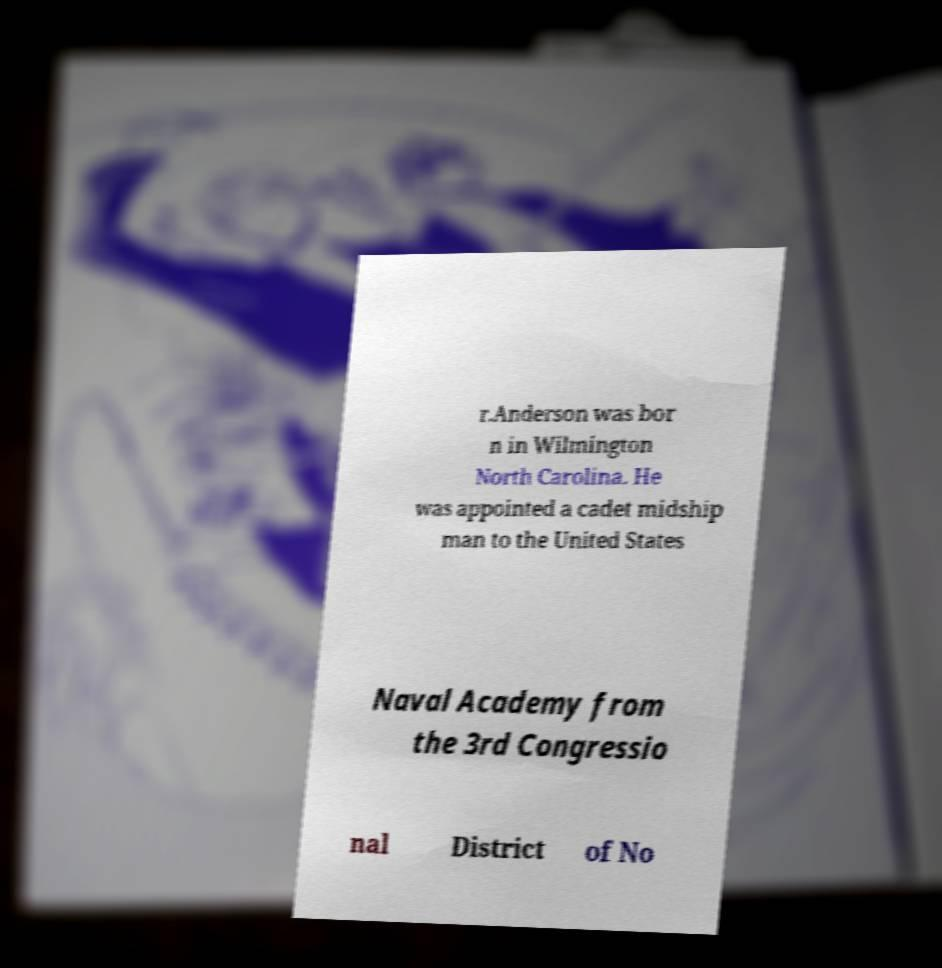Please identify and transcribe the text found in this image. r.Anderson was bor n in Wilmington North Carolina. He was appointed a cadet midship man to the United States Naval Academy from the 3rd Congressio nal District of No 